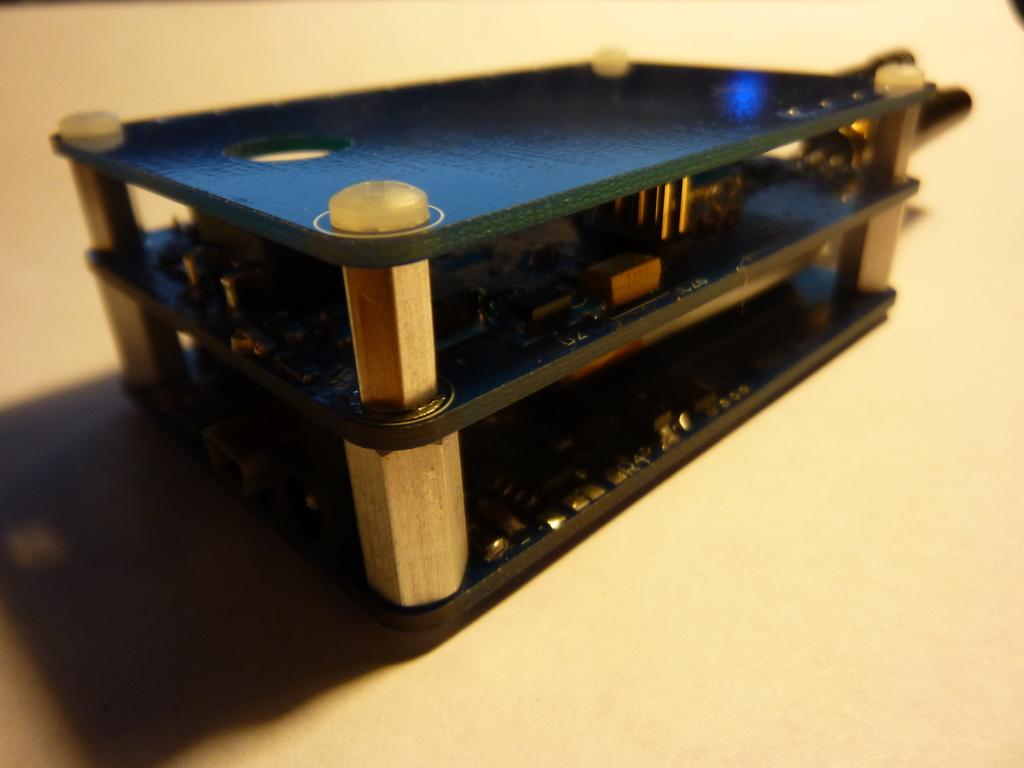What is the main subject in the center of the image? There is an object in the center of the image. Where is the object located? The object is on a table. What type of quilt is being used by the fireman near the stream in the image? There is no quilt, fireman, or stream present in the image. 